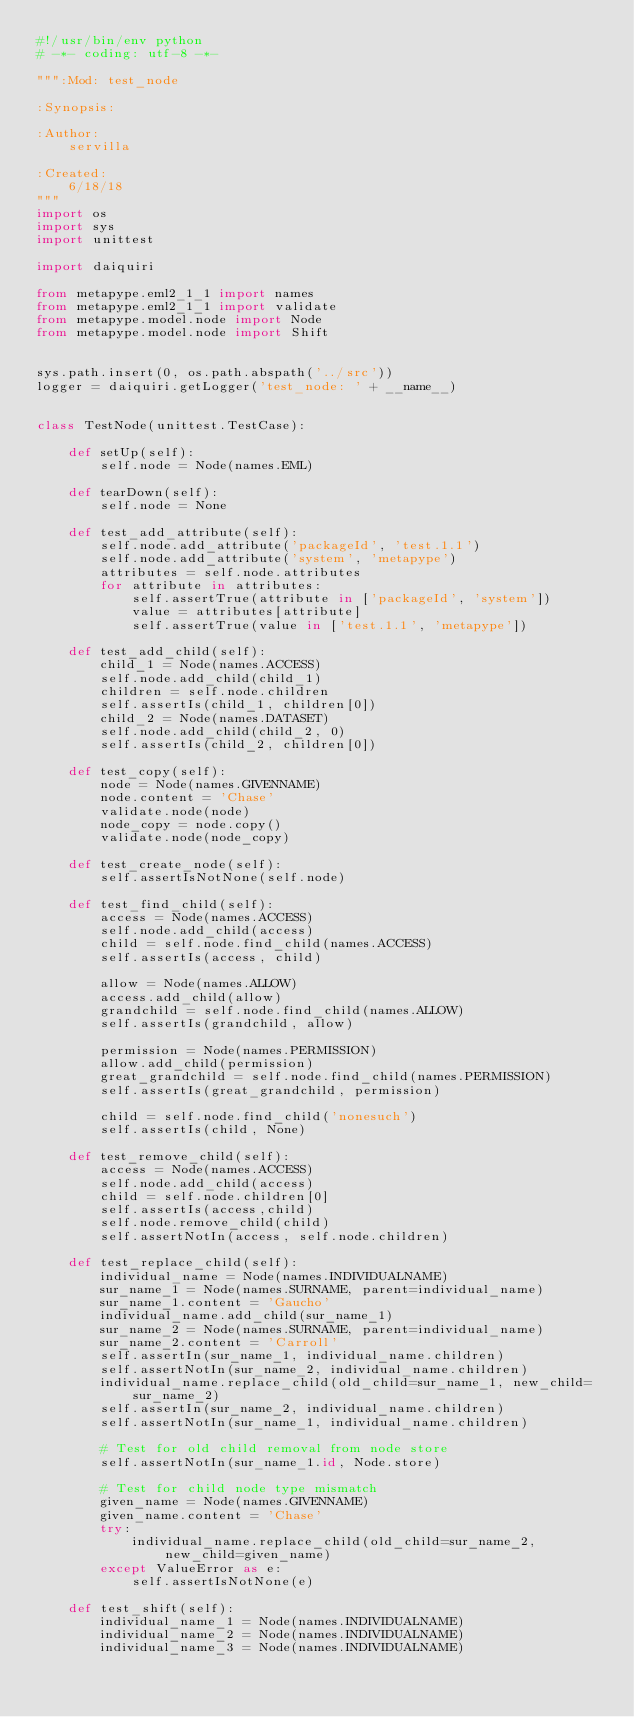<code> <loc_0><loc_0><loc_500><loc_500><_Python_>#!/usr/bin/env python
# -*- coding: utf-8 -*-

""":Mod: test_node

:Synopsis:

:Author:
    servilla
  
:Created:
    6/18/18
"""
import os
import sys
import unittest

import daiquiri

from metapype.eml2_1_1 import names
from metapype.eml2_1_1 import validate
from metapype.model.node import Node
from metapype.model.node import Shift


sys.path.insert(0, os.path.abspath('../src'))
logger = daiquiri.getLogger('test_node: ' + __name__)


class TestNode(unittest.TestCase):

    def setUp(self):
        self.node = Node(names.EML)

    def tearDown(self):
        self.node = None

    def test_add_attribute(self):
        self.node.add_attribute('packageId', 'test.1.1')
        self.node.add_attribute('system', 'metapype')
        attributes = self.node.attributes
        for attribute in attributes:
            self.assertTrue(attribute in ['packageId', 'system'])
            value = attributes[attribute]
            self.assertTrue(value in ['test.1.1', 'metapype'])

    def test_add_child(self):
        child_1 = Node(names.ACCESS)
        self.node.add_child(child_1)
        children = self.node.children
        self.assertIs(child_1, children[0])
        child_2 = Node(names.DATASET)
        self.node.add_child(child_2, 0)
        self.assertIs(child_2, children[0])

    def test_copy(self):
        node = Node(names.GIVENNAME)
        node.content = 'Chase'
        validate.node(node)
        node_copy = node.copy()
        validate.node(node_copy)

    def test_create_node(self):
        self.assertIsNotNone(self.node)

    def test_find_child(self):
        access = Node(names.ACCESS)
        self.node.add_child(access)
        child = self.node.find_child(names.ACCESS)
        self.assertIs(access, child)

        allow = Node(names.ALLOW)
        access.add_child(allow)
        grandchild = self.node.find_child(names.ALLOW)
        self.assertIs(grandchild, allow)

        permission = Node(names.PERMISSION)
        allow.add_child(permission)
        great_grandchild = self.node.find_child(names.PERMISSION)
        self.assertIs(great_grandchild, permission)

        child = self.node.find_child('nonesuch')
        self.assertIs(child, None)
        
    def test_remove_child(self):
        access = Node(names.ACCESS)
        self.node.add_child(access)
        child = self.node.children[0]
        self.assertIs(access,child)
        self.node.remove_child(child)
        self.assertNotIn(access, self.node.children)

    def test_replace_child(self):
        individual_name = Node(names.INDIVIDUALNAME)
        sur_name_1 = Node(names.SURNAME, parent=individual_name)
        sur_name_1.content = 'Gaucho'
        individual_name.add_child(sur_name_1)
        sur_name_2 = Node(names.SURNAME, parent=individual_name)
        sur_name_2.content = 'Carroll'
        self.assertIn(sur_name_1, individual_name.children)
        self.assertNotIn(sur_name_2, individual_name.children)
        individual_name.replace_child(old_child=sur_name_1, new_child=sur_name_2)
        self.assertIn(sur_name_2, individual_name.children)
        self.assertNotIn(sur_name_1, individual_name.children)

        # Test for old child removal from node store
        self.assertNotIn(sur_name_1.id, Node.store)

        # Test for child node type mismatch
        given_name = Node(names.GIVENNAME)
        given_name.content = 'Chase'
        try:
            individual_name.replace_child(old_child=sur_name_2, new_child=given_name)
        except ValueError as e:
            self.assertIsNotNone(e)

    def test_shift(self):
        individual_name_1 = Node(names.INDIVIDUALNAME)
        individual_name_2 = Node(names.INDIVIDUALNAME)
        individual_name_3 = Node(names.INDIVIDUALNAME)</code> 